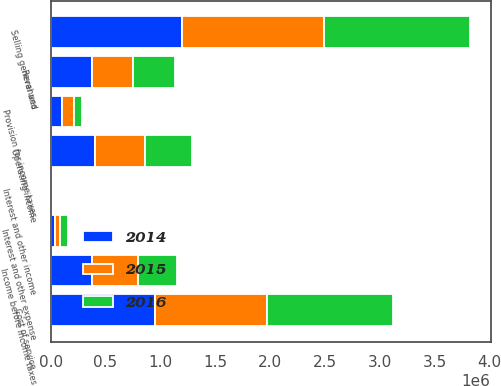Convert chart to OTSL. <chart><loc_0><loc_0><loc_500><loc_500><stacked_bar_chart><ecel><fcel>Revenues<fcel>Cost of service<fcel>Selling general and<fcel>Operating income<fcel>Interest and other income<fcel>Interest and other expense<fcel>Income before income taxes<fcel>Provision for income taxes<nl><fcel>2016<fcel>377350<fcel>1.14764e+06<fcel>1.32557e+06<fcel>424944<fcel>5284<fcel>69316<fcel>360912<fcel>70695<nl><fcel>2015<fcel>377350<fcel>1.02211e+06<fcel>1.29501e+06<fcel>456597<fcel>4949<fcel>44436<fcel>417110<fcel>107995<nl><fcel>2014<fcel>377350<fcel>952225<fcel>1.19651e+06<fcel>405499<fcel>13663<fcel>41812<fcel>377350<fcel>107398<nl></chart> 